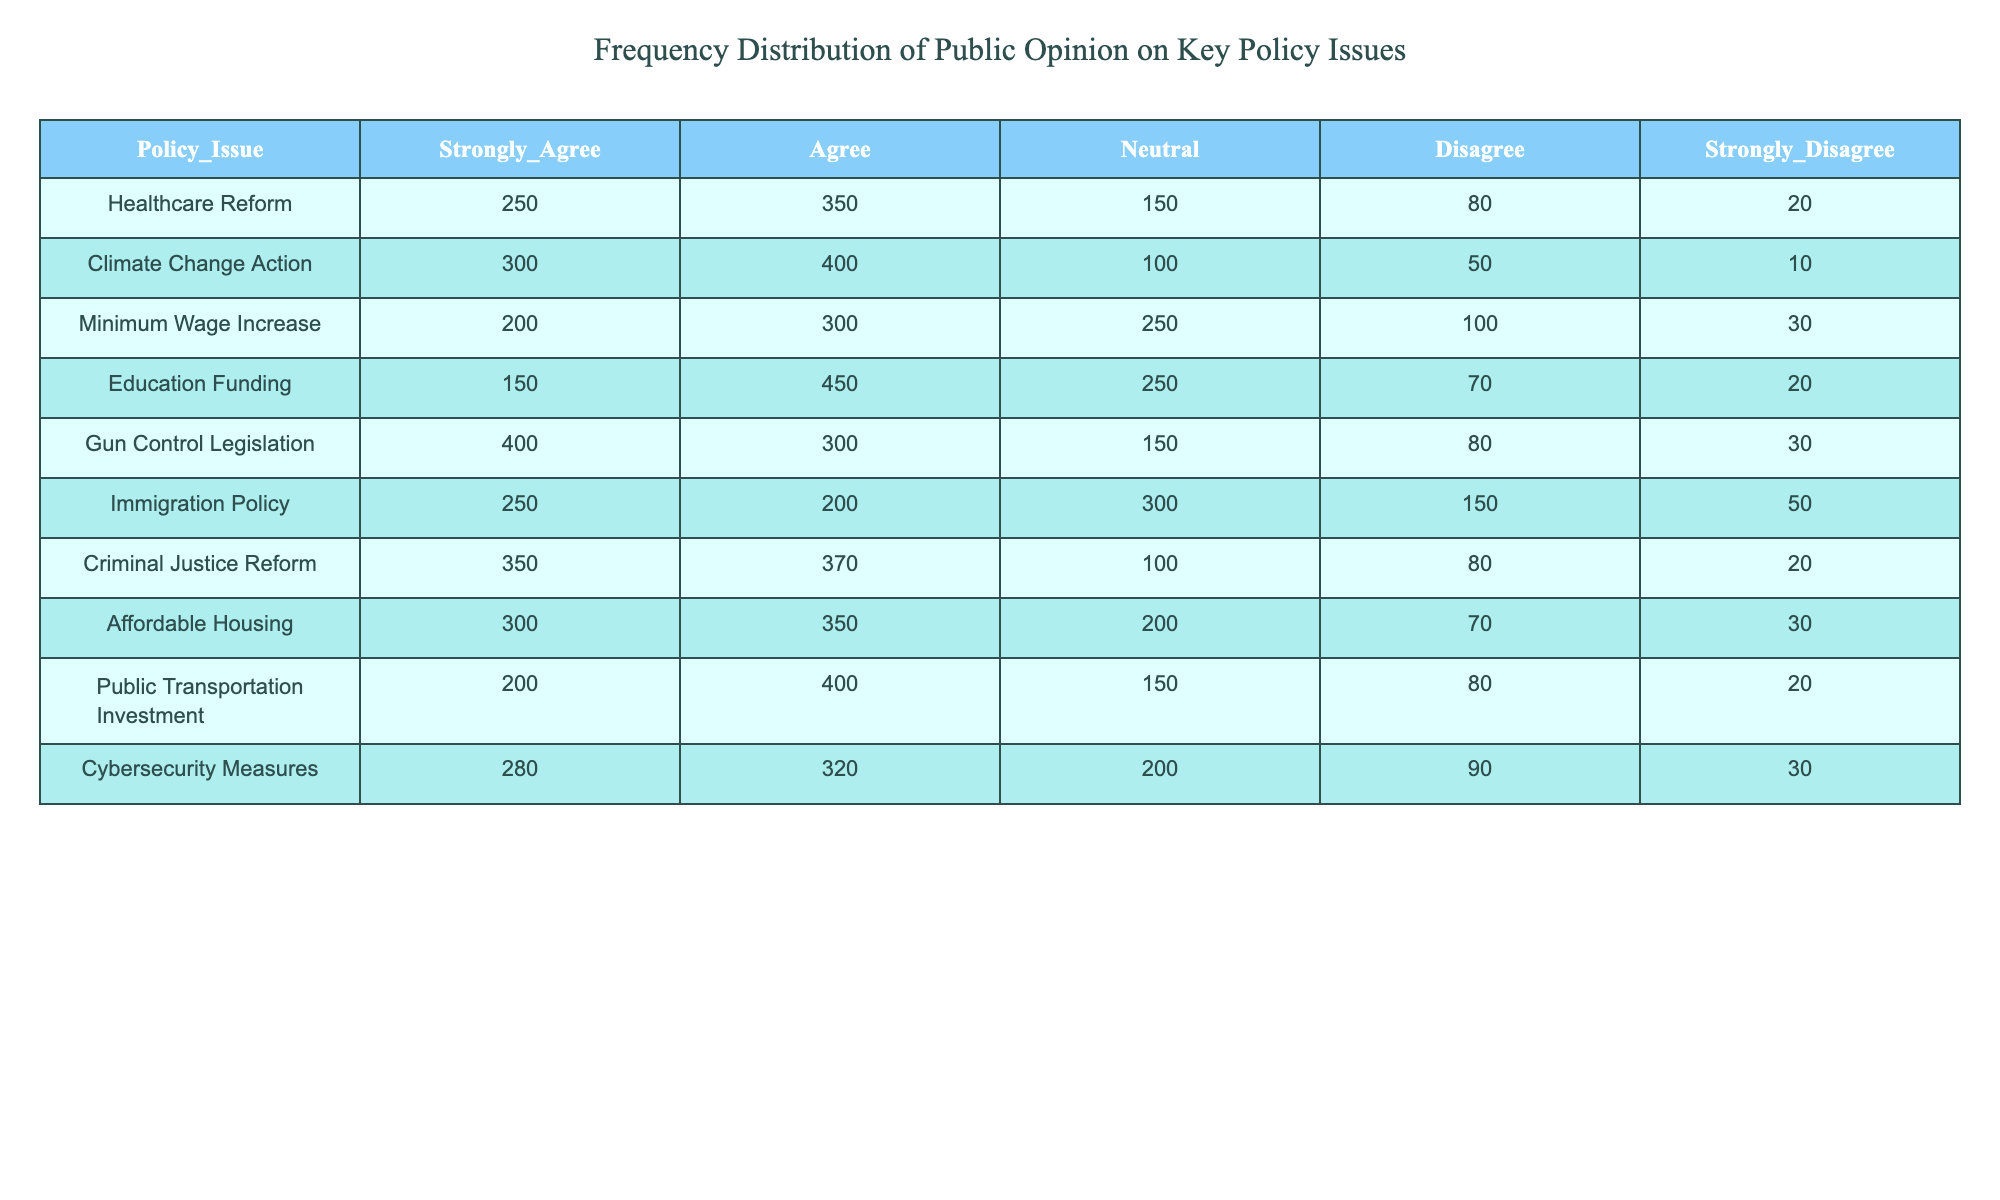What is the highest number of responses for "Strongly Agree" among the policy issues? By scanning the "Strongly Agree" column, we can locate the maximum value. The values are: 250 for Healthcare Reform, 300 for Climate Change Action, 200 for Minimum Wage Increase, 150 for Education Funding, 400 for Gun Control Legislation, 250 for Immigration Policy, 350 for Criminal Justice Reform, 300 for Affordable Housing, 200 for Public Transportation Investment, and 280 for Cybersecurity Measures. The highest value is 400 for Gun Control Legislation.
Answer: 400 Which policy issue has the least "Disagree" responses? Examining the "Disagree" column, the values are: 80 for Healthcare Reform, 50 for Climate Change Action, 100 for Minimum Wage Increase, 70 for Education Funding, 80 for Gun Control Legislation, 150 for Immigration Policy, 80 for Criminal Justice Reform, 70 for Affordable Housing, 80 for Public Transportation Investment, and 90 for Cybersecurity Measures. The minimum value is 50, which corresponds to Climate Change Action.
Answer: Climate Change Action Calculate the total number of responses for the policy issue "Education Funding." To find the total responses for Education Funding, we sum all the values in that row: 150 (Strongly Agree) + 450 (Agree) + 250 (Neutral) + 70 (Disagree) + 20 (Strongly Disagree) = 940.
Answer: 940 Is the total number of "Strongly Disagree" responses greater than those who "Strongly Agree"? Summing the "Strongly Disagree" values yields: 20 (Healthcare Reform) + 10 (Climate Change Action) + 30 (Minimum Wage Increase) + 20 (Education Funding) + 30 (Gun Control Legislation) + 50 (Immigration Policy) + 20 (Criminal Justice Reform) + 30 (Affordable Housing) + 20 (Public Transportation Investment) + 30 (Cybersecurity Measures) = 350. The "Strongly Agree" total is 250 + 300 + 200 + 150 + 400 + 250 + 350 + 300 + 200 + 280 = 2900. Since 350 < 2900, the answer is no.
Answer: No What is the average number of "Neutral" responses across all policy issues? The "Neutral" column values are: 150, 100, 250, 250, 150, 300, 100, 200, 150, and 200. To find the average, we first sum those values: 150 + 100 + 250 + 250 + 150 + 300 + 100 + 200 + 150 + 200 = 1900. Since there are 10 policy issues, the average is 1900 divided by 10, which is 190.
Answer: 190 